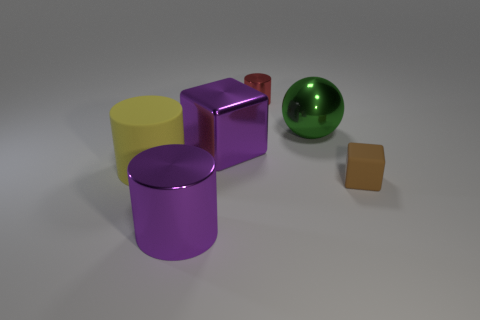Are there fewer large shiny blocks than tiny yellow objects?
Offer a very short reply. No. Is the number of rubber cylinders that are in front of the red object greater than the number of purple metal cubes that are right of the brown rubber block?
Make the answer very short. Yes. Does the tiny red thing have the same material as the large sphere?
Give a very brief answer. Yes. How many purple metal cylinders are in front of the large purple metal cylinder that is in front of the tiny rubber block?
Ensure brevity in your answer.  0. There is a block that is behind the tiny rubber thing; is it the same color as the small metal thing?
Provide a short and direct response. No. How many objects are green metallic balls or cubes that are left of the tiny cylinder?
Give a very brief answer. 2. Is the shape of the tiny object to the right of the big green metallic object the same as the big purple metal object behind the brown rubber thing?
Offer a very short reply. Yes. Are there any other things of the same color as the shiny ball?
Offer a very short reply. No. What is the shape of the small red object that is made of the same material as the green object?
Provide a short and direct response. Cylinder. There is a object that is on the right side of the large purple metal cylinder and to the left of the small shiny object; what is its material?
Your answer should be very brief. Metal. 